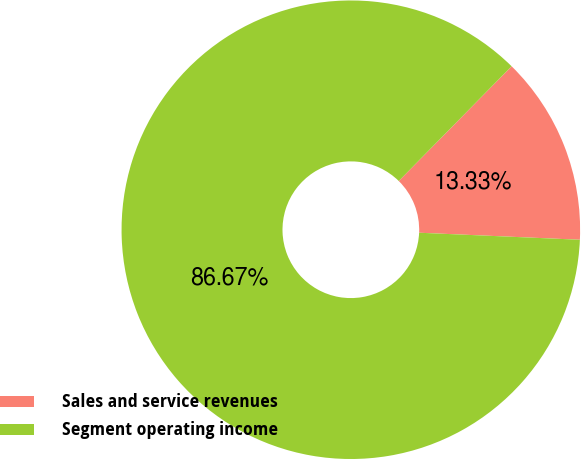<chart> <loc_0><loc_0><loc_500><loc_500><pie_chart><fcel>Sales and service revenues<fcel>Segment operating income<nl><fcel>13.33%<fcel>86.67%<nl></chart> 